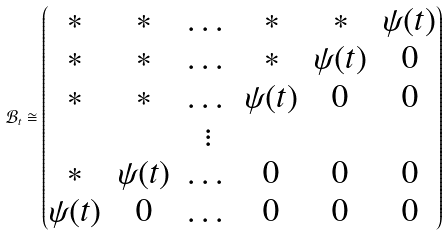Convert formula to latex. <formula><loc_0><loc_0><loc_500><loc_500>\mathcal { B } _ { t } \cong \begin{pmatrix} * & * & \dots & * & * & \psi ( t ) \\ * & * & \dots & * & \psi ( t ) & 0 \\ * & * & \dots & \psi ( t ) & 0 & 0 \\ & & \vdots \\ * & \psi ( t ) & \dots & 0 & 0 & 0 \\ \psi ( t ) & 0 & \dots & 0 & 0 & 0 \end{pmatrix}</formula> 